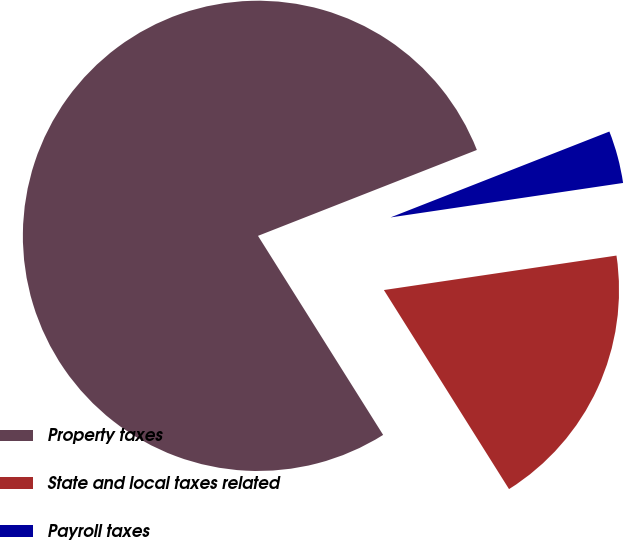Convert chart. <chart><loc_0><loc_0><loc_500><loc_500><pie_chart><fcel>Property taxes<fcel>State and local taxes related<fcel>Payroll taxes<nl><fcel>77.98%<fcel>18.41%<fcel>3.61%<nl></chart> 